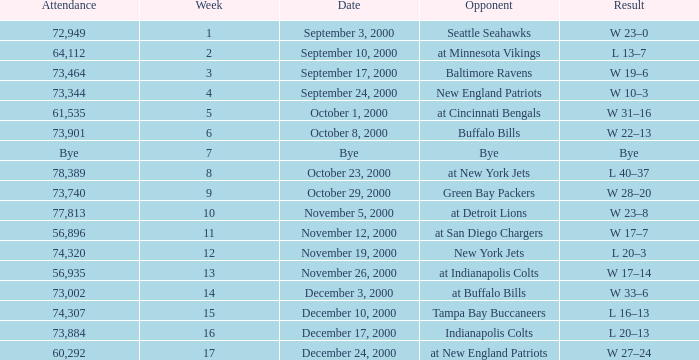What is the Result of the game against the Indianapolis Colts? L 20–13. Could you help me parse every detail presented in this table? {'header': ['Attendance', 'Week', 'Date', 'Opponent', 'Result'], 'rows': [['72,949', '1', 'September 3, 2000', 'Seattle Seahawks', 'W 23–0'], ['64,112', '2', 'September 10, 2000', 'at Minnesota Vikings', 'L 13–7'], ['73,464', '3', 'September 17, 2000', 'Baltimore Ravens', 'W 19–6'], ['73,344', '4', 'September 24, 2000', 'New England Patriots', 'W 10–3'], ['61,535', '5', 'October 1, 2000', 'at Cincinnati Bengals', 'W 31–16'], ['73,901', '6', 'October 8, 2000', 'Buffalo Bills', 'W 22–13'], ['Bye', '7', 'Bye', 'Bye', 'Bye'], ['78,389', '8', 'October 23, 2000', 'at New York Jets', 'L 40–37'], ['73,740', '9', 'October 29, 2000', 'Green Bay Packers', 'W 28–20'], ['77,813', '10', 'November 5, 2000', 'at Detroit Lions', 'W 23–8'], ['56,896', '11', 'November 12, 2000', 'at San Diego Chargers', 'W 17–7'], ['74,320', '12', 'November 19, 2000', 'New York Jets', 'L 20–3'], ['56,935', '13', 'November 26, 2000', 'at Indianapolis Colts', 'W 17–14'], ['73,002', '14', 'December 3, 2000', 'at Buffalo Bills', 'W 33–6'], ['74,307', '15', 'December 10, 2000', 'Tampa Bay Buccaneers', 'L 16–13'], ['73,884', '16', 'December 17, 2000', 'Indianapolis Colts', 'L 20–13'], ['60,292', '17', 'December 24, 2000', 'at New England Patriots', 'W 27–24']]} 